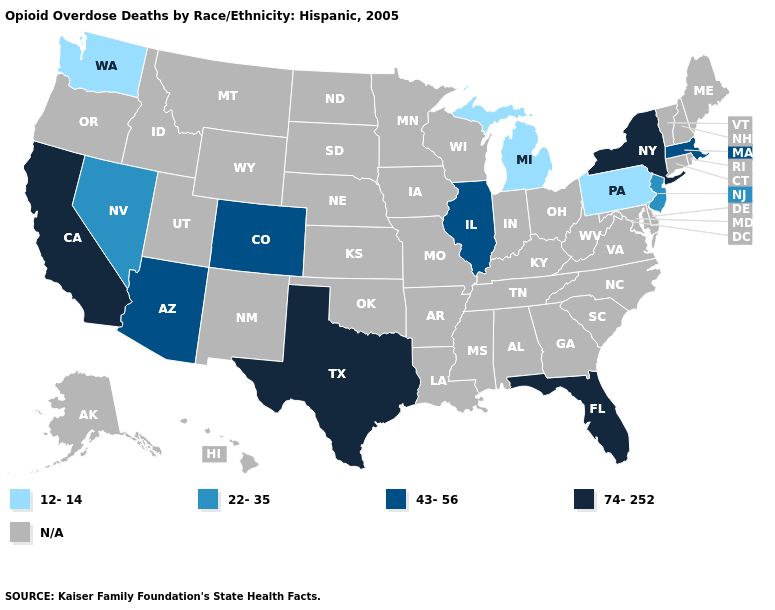What is the value of South Dakota?
Answer briefly. N/A. What is the value of Nebraska?
Answer briefly. N/A. Name the states that have a value in the range 22-35?
Quick response, please. Nevada, New Jersey. Name the states that have a value in the range 12-14?
Concise answer only. Michigan, Pennsylvania, Washington. Name the states that have a value in the range 74-252?
Give a very brief answer. California, Florida, New York, Texas. Is the legend a continuous bar?
Be succinct. No. What is the value of Oklahoma?
Concise answer only. N/A. What is the value of Mississippi?
Keep it brief. N/A. Name the states that have a value in the range N/A?
Give a very brief answer. Alabama, Alaska, Arkansas, Connecticut, Delaware, Georgia, Hawaii, Idaho, Indiana, Iowa, Kansas, Kentucky, Louisiana, Maine, Maryland, Minnesota, Mississippi, Missouri, Montana, Nebraska, New Hampshire, New Mexico, North Carolina, North Dakota, Ohio, Oklahoma, Oregon, Rhode Island, South Carolina, South Dakota, Tennessee, Utah, Vermont, Virginia, West Virginia, Wisconsin, Wyoming. Name the states that have a value in the range 43-56?
Keep it brief. Arizona, Colorado, Illinois, Massachusetts. Name the states that have a value in the range 43-56?
Give a very brief answer. Arizona, Colorado, Illinois, Massachusetts. 